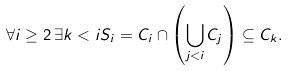Convert formula to latex. <formula><loc_0><loc_0><loc_500><loc_500>\forall i \geq 2 \, \exists k < i S _ { i } = C _ { i } \cap \left ( \bigcup _ { j < i } C _ { j } \right ) \subseteq C _ { k } .</formula> 